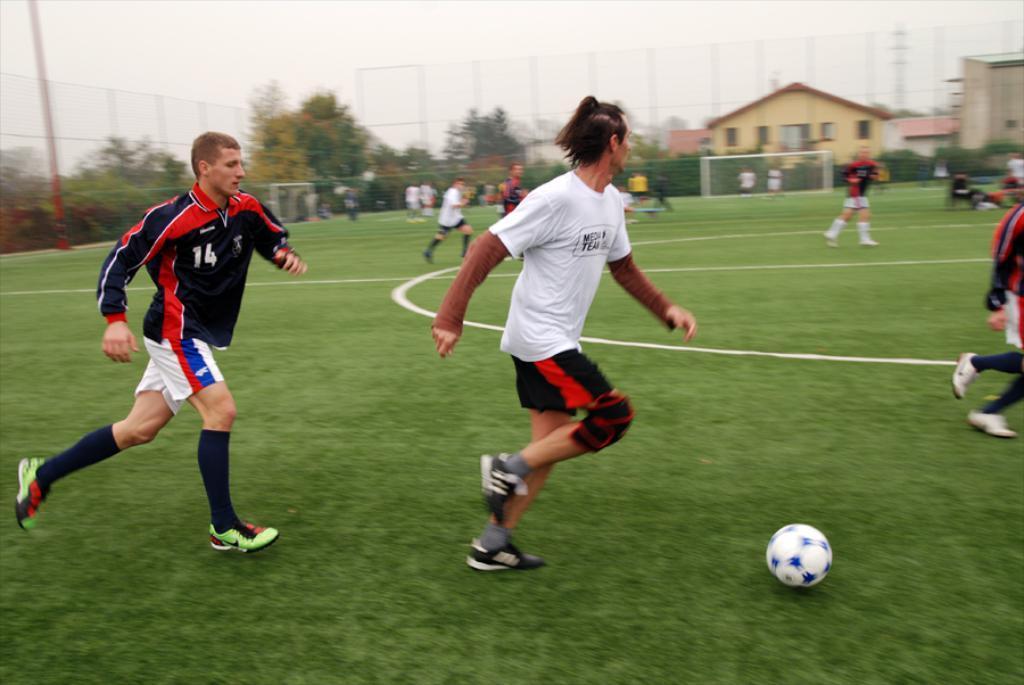In one or two sentences, can you explain what this image depicts? In this image there is the sky, there is a fencing, there are trees, there is a house, there is a building truncated towards the right of the image, there is a playground, there are players playing football, there is grass, there is football, there is a person truncated towards the right of the image, there is a goal post. 